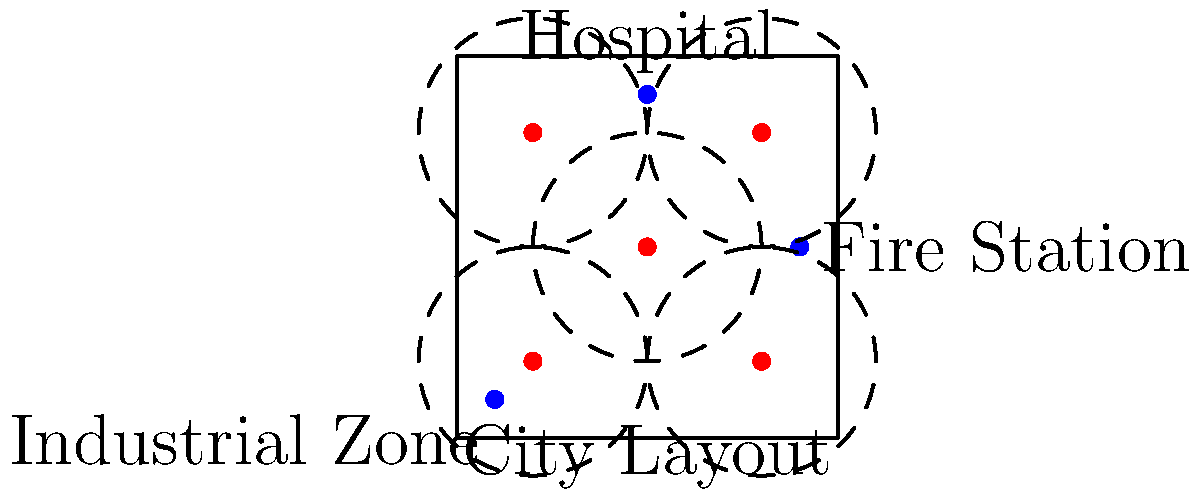Given the city layout above, where red dots represent potential helipad locations and blue dots represent key facilities, which combination of two helipad locations would provide the most optimal coverage for emergency operations? Assume each helipad has a 3-unit radius of effective coverage. To determine the optimal placement of two helipads, we need to consider the following steps:

1. Analyze the coverage of each potential helipad location:
   - Center (0,0): Covers the central area, partially covers all key facilities
   - Top-right (3,3): Covers the hospital well, partially covers the fire station
   - Bottom-left (-3,-3): Covers the industrial zone well, partially covers the center
   - Bottom-right (3,-3): Covers the southern area, partially covers the fire station
   - Top-left (-3,3): Covers the northern area, partially covers the hospital

2. Consider the importance of key facilities:
   - Hospital: Critical for medical emergencies
   - Fire Station: Important for coordinating emergency responses
   - Industrial Zone: Potential high-risk area for accidents

3. Evaluate coverage combinations:
   - (0,0) and (3,3): Good central and northeastern coverage, includes hospital and fire station
   - (0,0) and (-3,-3): Good central and southwestern coverage, includes industrial zone
   - (3,3) and (-3,-3): Diagonal coverage, includes all key facilities but leaves central area exposed

4. Assess overall city coverage:
   - The combination of (0,0) and (-3,-3) provides the best overall coverage of the city area

5. Consider emergency response efficiency:
   - The central helipad (0,0) allows quick access to all areas
   - The bottom-left helipad (-3,-3) covers the industrial zone and complements the central coverage

Therefore, the most optimal combination is the central helipad (0,0) and the bottom-left helipad (-3,-3). This combination provides maximum coverage of the city area, includes all key facilities within the coverage radius, and allows for efficient emergency response to all parts of the city.
Answer: (0,0) and (-3,-3) 